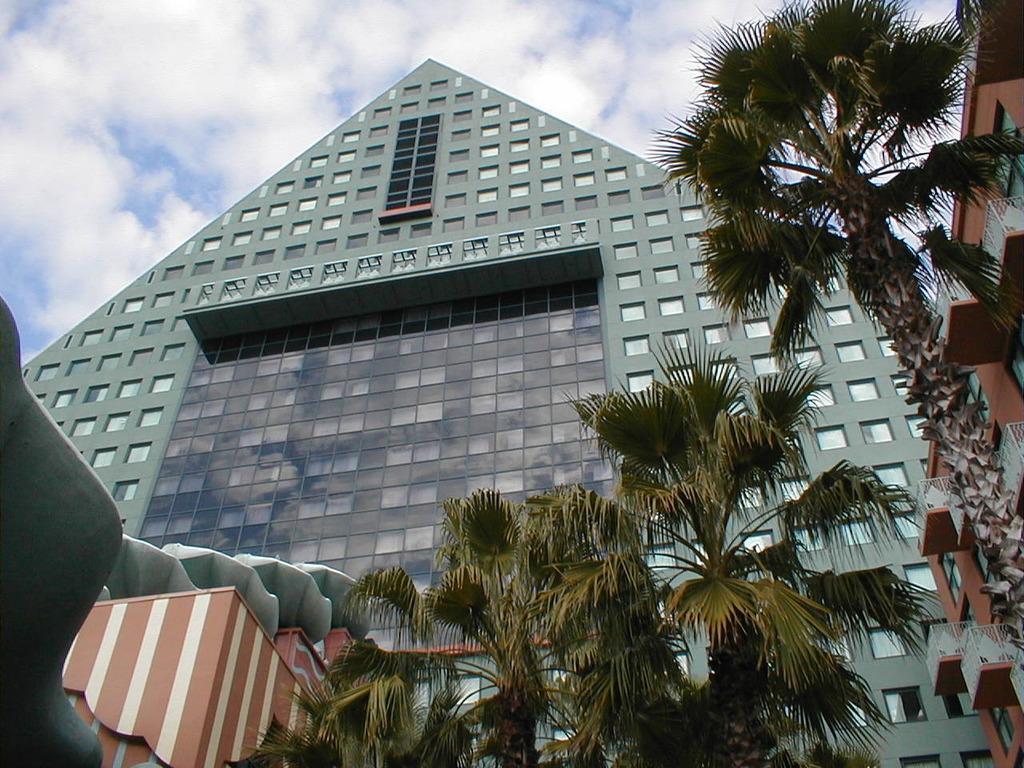In one or two sentences, can you explain what this image depicts? We can see buildings, trees, railings and windows. In the background we can see sky with clouds. 